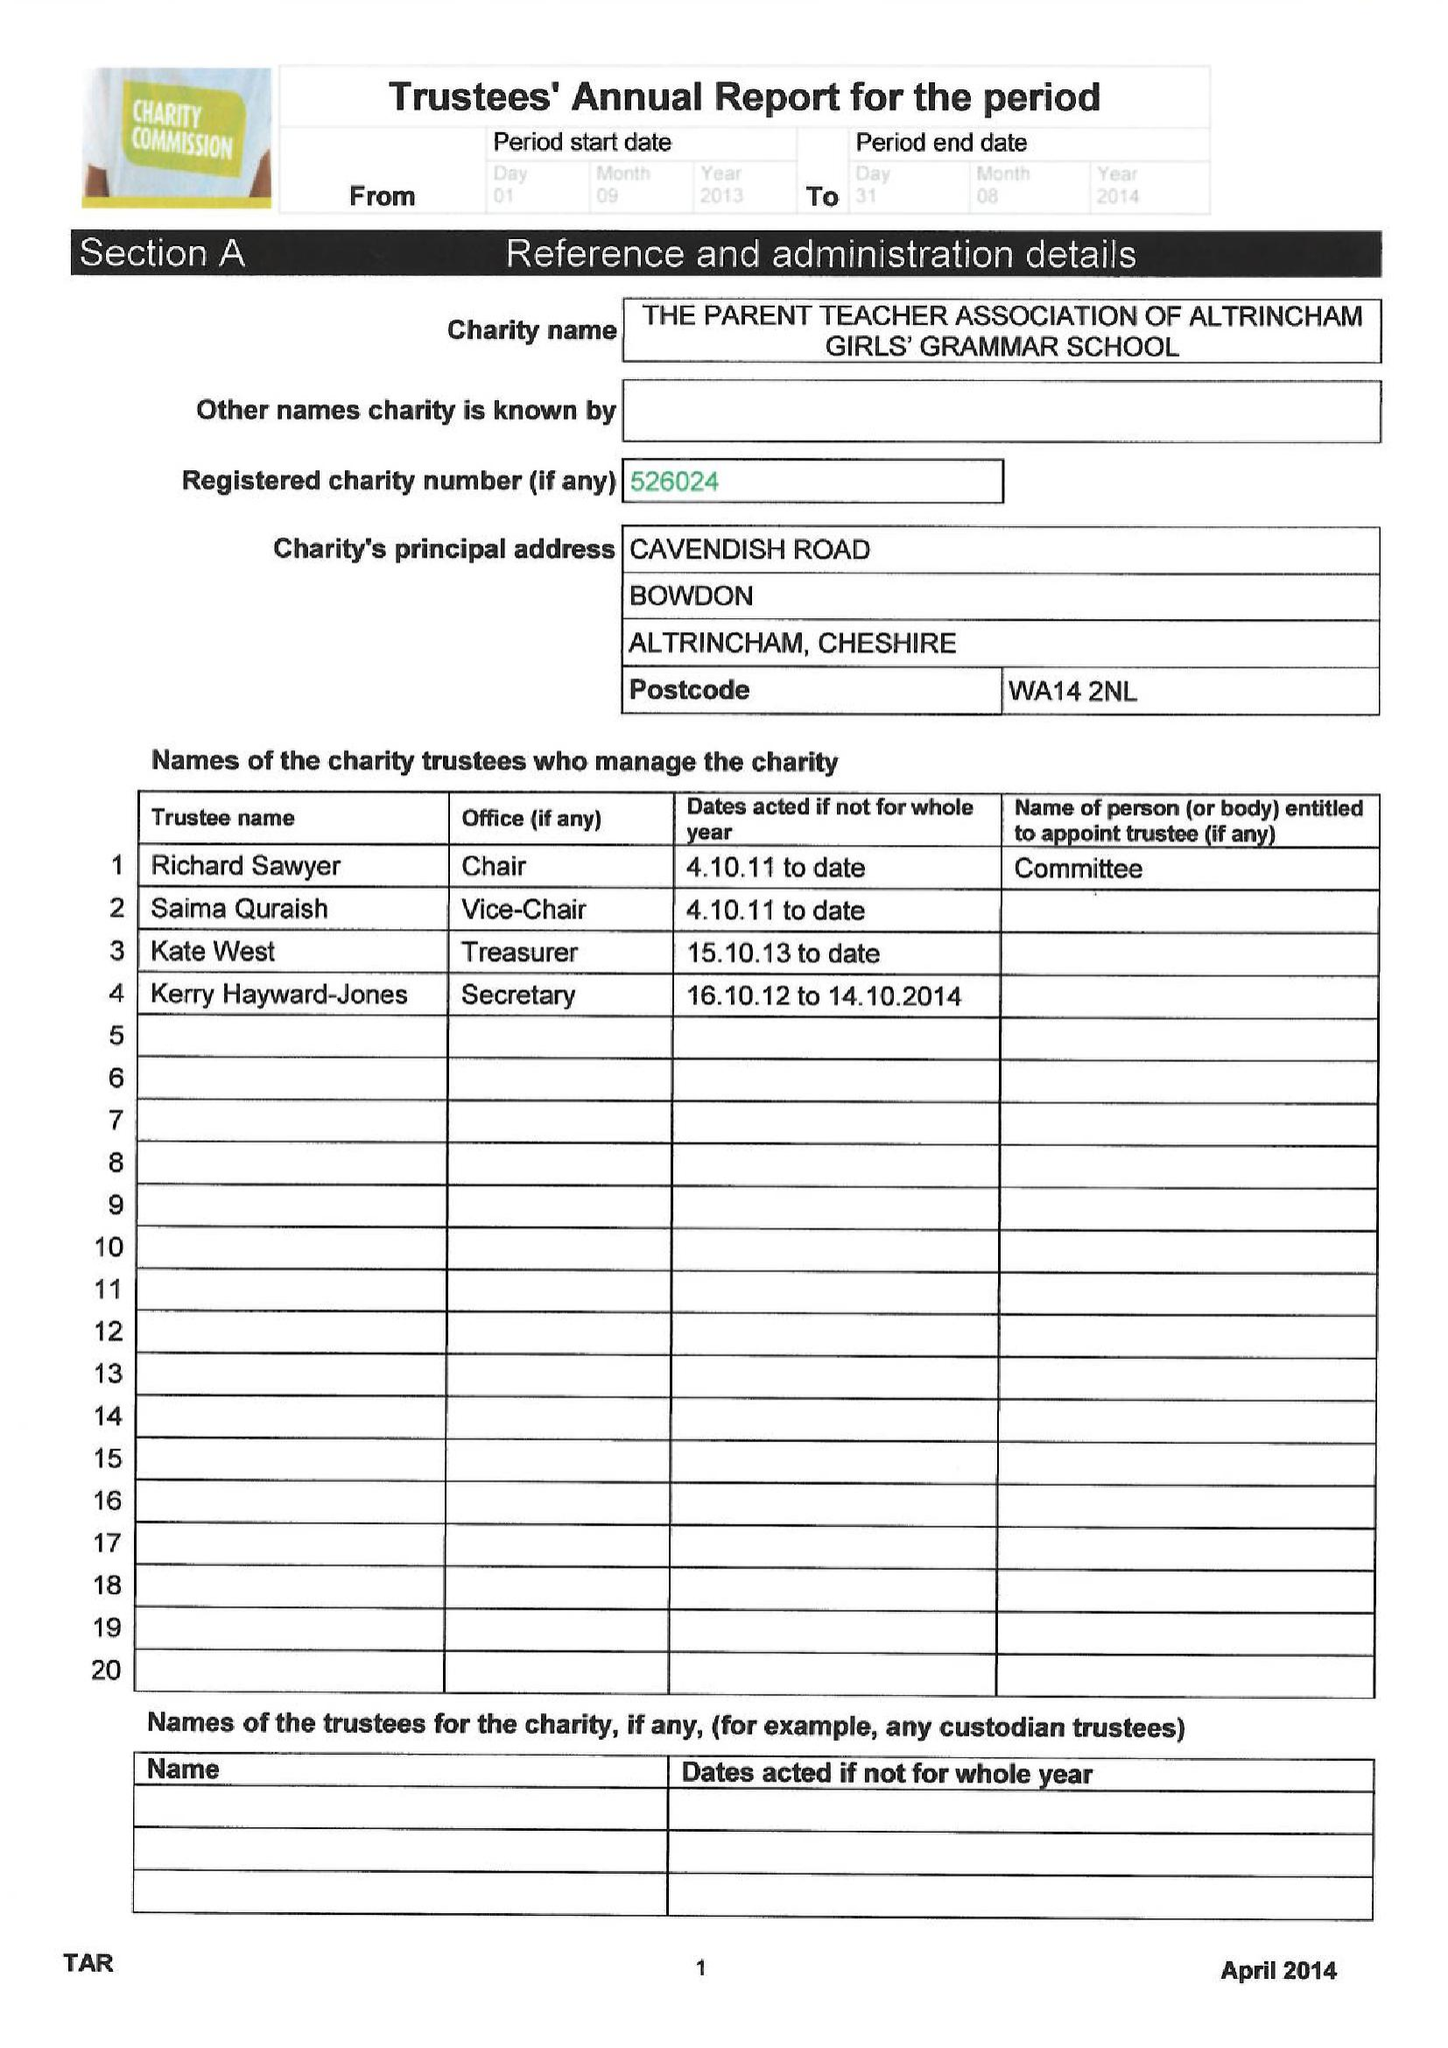What is the value for the spending_annually_in_british_pounds?
Answer the question using a single word or phrase. 70848.00 